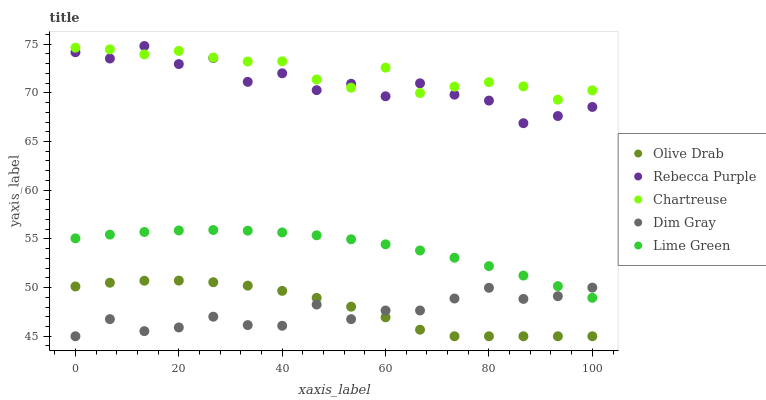Does Dim Gray have the minimum area under the curve?
Answer yes or no. Yes. Does Chartreuse have the maximum area under the curve?
Answer yes or no. Yes. Does Lime Green have the minimum area under the curve?
Answer yes or no. No. Does Lime Green have the maximum area under the curve?
Answer yes or no. No. Is Lime Green the smoothest?
Answer yes or no. Yes. Is Rebecca Purple the roughest?
Answer yes or no. Yes. Is Dim Gray the smoothest?
Answer yes or no. No. Is Dim Gray the roughest?
Answer yes or no. No. Does Dim Gray have the lowest value?
Answer yes or no. Yes. Does Lime Green have the lowest value?
Answer yes or no. No. Does Rebecca Purple have the highest value?
Answer yes or no. Yes. Does Lime Green have the highest value?
Answer yes or no. No. Is Lime Green less than Rebecca Purple?
Answer yes or no. Yes. Is Chartreuse greater than Lime Green?
Answer yes or no. Yes. Does Dim Gray intersect Lime Green?
Answer yes or no. Yes. Is Dim Gray less than Lime Green?
Answer yes or no. No. Is Dim Gray greater than Lime Green?
Answer yes or no. No. Does Lime Green intersect Rebecca Purple?
Answer yes or no. No. 